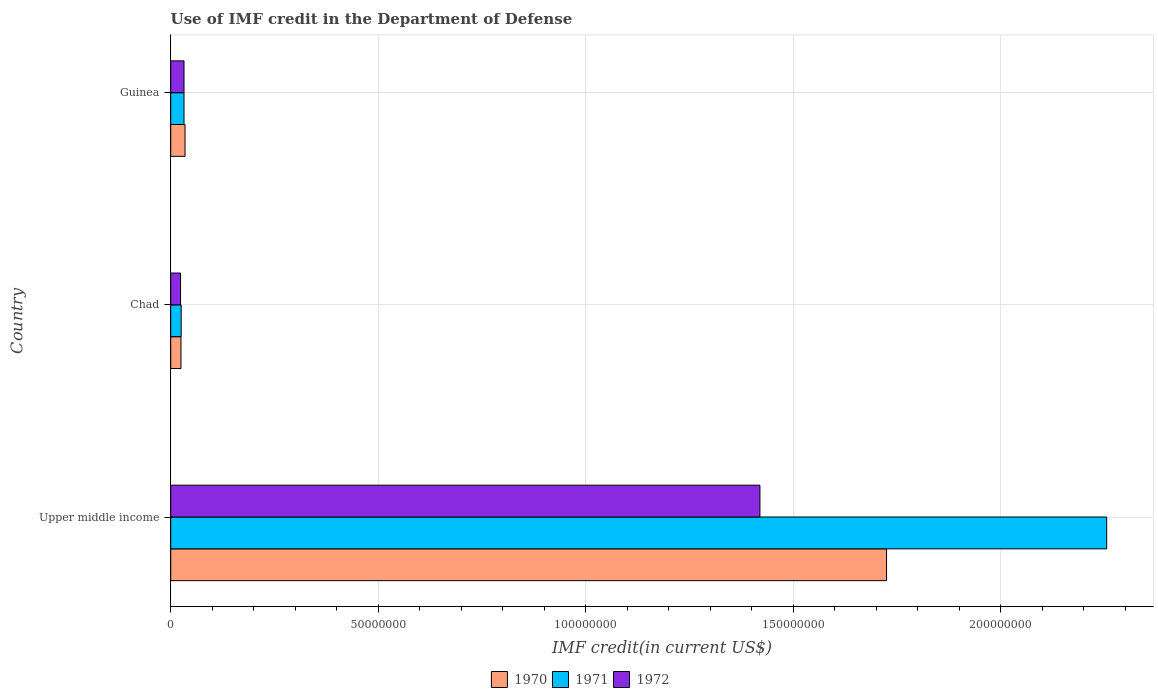How many different coloured bars are there?
Offer a terse response. 3. How many groups of bars are there?
Your response must be concise. 3. How many bars are there on the 1st tick from the top?
Provide a short and direct response. 3. What is the label of the 3rd group of bars from the top?
Your response must be concise. Upper middle income. What is the IMF credit in the Department of Defense in 1972 in Upper middle income?
Offer a very short reply. 1.42e+08. Across all countries, what is the maximum IMF credit in the Department of Defense in 1972?
Provide a succinct answer. 1.42e+08. Across all countries, what is the minimum IMF credit in the Department of Defense in 1970?
Your answer should be very brief. 2.47e+06. In which country was the IMF credit in the Department of Defense in 1972 maximum?
Offer a terse response. Upper middle income. In which country was the IMF credit in the Department of Defense in 1972 minimum?
Ensure brevity in your answer.  Chad. What is the total IMF credit in the Department of Defense in 1972 in the graph?
Offer a very short reply. 1.48e+08. What is the difference between the IMF credit in the Department of Defense in 1970 in Chad and that in Upper middle income?
Keep it short and to the point. -1.70e+08. What is the difference between the IMF credit in the Department of Defense in 1972 in Upper middle income and the IMF credit in the Department of Defense in 1971 in Guinea?
Give a very brief answer. 1.39e+08. What is the average IMF credit in the Department of Defense in 1972 per country?
Your answer should be very brief. 4.92e+07. What is the difference between the IMF credit in the Department of Defense in 1972 and IMF credit in the Department of Defense in 1971 in Chad?
Your answer should be compact. -1.52e+05. In how many countries, is the IMF credit in the Department of Defense in 1971 greater than 40000000 US$?
Ensure brevity in your answer.  1. What is the ratio of the IMF credit in the Department of Defense in 1972 in Chad to that in Upper middle income?
Offer a terse response. 0.02. Is the IMF credit in the Department of Defense in 1972 in Chad less than that in Upper middle income?
Provide a succinct answer. Yes. Is the difference between the IMF credit in the Department of Defense in 1972 in Guinea and Upper middle income greater than the difference between the IMF credit in the Department of Defense in 1971 in Guinea and Upper middle income?
Offer a terse response. Yes. What is the difference between the highest and the second highest IMF credit in the Department of Defense in 1970?
Offer a very short reply. 1.69e+08. What is the difference between the highest and the lowest IMF credit in the Department of Defense in 1970?
Offer a terse response. 1.70e+08. In how many countries, is the IMF credit in the Department of Defense in 1971 greater than the average IMF credit in the Department of Defense in 1971 taken over all countries?
Make the answer very short. 1. Is the sum of the IMF credit in the Department of Defense in 1970 in Chad and Upper middle income greater than the maximum IMF credit in the Department of Defense in 1972 across all countries?
Give a very brief answer. Yes. What does the 3rd bar from the top in Chad represents?
Ensure brevity in your answer.  1970. What does the 3rd bar from the bottom in Chad represents?
Provide a short and direct response. 1972. Is it the case that in every country, the sum of the IMF credit in the Department of Defense in 1970 and IMF credit in the Department of Defense in 1972 is greater than the IMF credit in the Department of Defense in 1971?
Your answer should be very brief. Yes. How many countries are there in the graph?
Ensure brevity in your answer.  3. What is the difference between two consecutive major ticks on the X-axis?
Offer a very short reply. 5.00e+07. Are the values on the major ticks of X-axis written in scientific E-notation?
Your answer should be very brief. No. Does the graph contain grids?
Offer a very short reply. Yes. How are the legend labels stacked?
Your answer should be very brief. Horizontal. What is the title of the graph?
Provide a succinct answer. Use of IMF credit in the Department of Defense. Does "1973" appear as one of the legend labels in the graph?
Provide a short and direct response. No. What is the label or title of the X-axis?
Provide a succinct answer. IMF credit(in current US$). What is the label or title of the Y-axis?
Keep it short and to the point. Country. What is the IMF credit(in current US$) of 1970 in Upper middle income?
Give a very brief answer. 1.72e+08. What is the IMF credit(in current US$) in 1971 in Upper middle income?
Ensure brevity in your answer.  2.25e+08. What is the IMF credit(in current US$) of 1972 in Upper middle income?
Give a very brief answer. 1.42e+08. What is the IMF credit(in current US$) of 1970 in Chad?
Ensure brevity in your answer.  2.47e+06. What is the IMF credit(in current US$) in 1971 in Chad?
Offer a terse response. 2.52e+06. What is the IMF credit(in current US$) of 1972 in Chad?
Provide a succinct answer. 2.37e+06. What is the IMF credit(in current US$) of 1970 in Guinea?
Provide a succinct answer. 3.45e+06. What is the IMF credit(in current US$) in 1971 in Guinea?
Ensure brevity in your answer.  3.20e+06. What is the IMF credit(in current US$) in 1972 in Guinea?
Offer a very short reply. 3.20e+06. Across all countries, what is the maximum IMF credit(in current US$) of 1970?
Keep it short and to the point. 1.72e+08. Across all countries, what is the maximum IMF credit(in current US$) in 1971?
Offer a terse response. 2.25e+08. Across all countries, what is the maximum IMF credit(in current US$) of 1972?
Your answer should be very brief. 1.42e+08. Across all countries, what is the minimum IMF credit(in current US$) in 1970?
Your answer should be very brief. 2.47e+06. Across all countries, what is the minimum IMF credit(in current US$) of 1971?
Offer a very short reply. 2.52e+06. Across all countries, what is the minimum IMF credit(in current US$) of 1972?
Offer a terse response. 2.37e+06. What is the total IMF credit(in current US$) in 1970 in the graph?
Ensure brevity in your answer.  1.78e+08. What is the total IMF credit(in current US$) of 1971 in the graph?
Your answer should be compact. 2.31e+08. What is the total IMF credit(in current US$) in 1972 in the graph?
Your response must be concise. 1.48e+08. What is the difference between the IMF credit(in current US$) in 1970 in Upper middle income and that in Chad?
Offer a terse response. 1.70e+08. What is the difference between the IMF credit(in current US$) of 1971 in Upper middle income and that in Chad?
Provide a succinct answer. 2.23e+08. What is the difference between the IMF credit(in current US$) in 1972 in Upper middle income and that in Chad?
Offer a very short reply. 1.40e+08. What is the difference between the IMF credit(in current US$) in 1970 in Upper middle income and that in Guinea?
Offer a very short reply. 1.69e+08. What is the difference between the IMF credit(in current US$) in 1971 in Upper middle income and that in Guinea?
Provide a short and direct response. 2.22e+08. What is the difference between the IMF credit(in current US$) of 1972 in Upper middle income and that in Guinea?
Provide a short and direct response. 1.39e+08. What is the difference between the IMF credit(in current US$) of 1970 in Chad and that in Guinea?
Keep it short and to the point. -9.80e+05. What is the difference between the IMF credit(in current US$) in 1971 in Chad and that in Guinea?
Provide a succinct answer. -6.84e+05. What is the difference between the IMF credit(in current US$) in 1972 in Chad and that in Guinea?
Make the answer very short. -8.36e+05. What is the difference between the IMF credit(in current US$) of 1970 in Upper middle income and the IMF credit(in current US$) of 1971 in Chad?
Give a very brief answer. 1.70e+08. What is the difference between the IMF credit(in current US$) in 1970 in Upper middle income and the IMF credit(in current US$) in 1972 in Chad?
Provide a succinct answer. 1.70e+08. What is the difference between the IMF credit(in current US$) in 1971 in Upper middle income and the IMF credit(in current US$) in 1972 in Chad?
Keep it short and to the point. 2.23e+08. What is the difference between the IMF credit(in current US$) in 1970 in Upper middle income and the IMF credit(in current US$) in 1971 in Guinea?
Make the answer very short. 1.69e+08. What is the difference between the IMF credit(in current US$) of 1970 in Upper middle income and the IMF credit(in current US$) of 1972 in Guinea?
Offer a terse response. 1.69e+08. What is the difference between the IMF credit(in current US$) in 1971 in Upper middle income and the IMF credit(in current US$) in 1972 in Guinea?
Give a very brief answer. 2.22e+08. What is the difference between the IMF credit(in current US$) of 1970 in Chad and the IMF credit(in current US$) of 1971 in Guinea?
Make the answer very short. -7.33e+05. What is the difference between the IMF credit(in current US$) in 1970 in Chad and the IMF credit(in current US$) in 1972 in Guinea?
Offer a very short reply. -7.33e+05. What is the difference between the IMF credit(in current US$) in 1971 in Chad and the IMF credit(in current US$) in 1972 in Guinea?
Your answer should be compact. -6.84e+05. What is the average IMF credit(in current US$) of 1970 per country?
Give a very brief answer. 5.95e+07. What is the average IMF credit(in current US$) in 1971 per country?
Keep it short and to the point. 7.71e+07. What is the average IMF credit(in current US$) in 1972 per country?
Ensure brevity in your answer.  4.92e+07. What is the difference between the IMF credit(in current US$) of 1970 and IMF credit(in current US$) of 1971 in Upper middle income?
Offer a very short reply. -5.30e+07. What is the difference between the IMF credit(in current US$) in 1970 and IMF credit(in current US$) in 1972 in Upper middle income?
Your answer should be compact. 3.05e+07. What is the difference between the IMF credit(in current US$) of 1971 and IMF credit(in current US$) of 1972 in Upper middle income?
Offer a very short reply. 8.35e+07. What is the difference between the IMF credit(in current US$) in 1970 and IMF credit(in current US$) in 1971 in Chad?
Keep it short and to the point. -4.90e+04. What is the difference between the IMF credit(in current US$) in 1970 and IMF credit(in current US$) in 1972 in Chad?
Offer a terse response. 1.03e+05. What is the difference between the IMF credit(in current US$) of 1971 and IMF credit(in current US$) of 1972 in Chad?
Your answer should be compact. 1.52e+05. What is the difference between the IMF credit(in current US$) of 1970 and IMF credit(in current US$) of 1971 in Guinea?
Your answer should be very brief. 2.47e+05. What is the difference between the IMF credit(in current US$) in 1970 and IMF credit(in current US$) in 1972 in Guinea?
Your response must be concise. 2.47e+05. What is the difference between the IMF credit(in current US$) of 1971 and IMF credit(in current US$) of 1972 in Guinea?
Offer a terse response. 0. What is the ratio of the IMF credit(in current US$) in 1970 in Upper middle income to that in Chad?
Give a very brief answer. 69.82. What is the ratio of the IMF credit(in current US$) of 1971 in Upper middle income to that in Chad?
Your answer should be very brief. 89.51. What is the ratio of the IMF credit(in current US$) of 1972 in Upper middle income to that in Chad?
Your answer should be compact. 59.97. What is the ratio of the IMF credit(in current US$) in 1970 in Upper middle income to that in Guinea?
Make the answer very short. 49.99. What is the ratio of the IMF credit(in current US$) in 1971 in Upper middle income to that in Guinea?
Offer a terse response. 70.4. What is the ratio of the IMF credit(in current US$) in 1972 in Upper middle income to that in Guinea?
Offer a very short reply. 44.32. What is the ratio of the IMF credit(in current US$) of 1970 in Chad to that in Guinea?
Your answer should be very brief. 0.72. What is the ratio of the IMF credit(in current US$) of 1971 in Chad to that in Guinea?
Provide a short and direct response. 0.79. What is the ratio of the IMF credit(in current US$) in 1972 in Chad to that in Guinea?
Offer a terse response. 0.74. What is the difference between the highest and the second highest IMF credit(in current US$) of 1970?
Your answer should be very brief. 1.69e+08. What is the difference between the highest and the second highest IMF credit(in current US$) in 1971?
Give a very brief answer. 2.22e+08. What is the difference between the highest and the second highest IMF credit(in current US$) of 1972?
Keep it short and to the point. 1.39e+08. What is the difference between the highest and the lowest IMF credit(in current US$) of 1970?
Make the answer very short. 1.70e+08. What is the difference between the highest and the lowest IMF credit(in current US$) of 1971?
Ensure brevity in your answer.  2.23e+08. What is the difference between the highest and the lowest IMF credit(in current US$) in 1972?
Make the answer very short. 1.40e+08. 